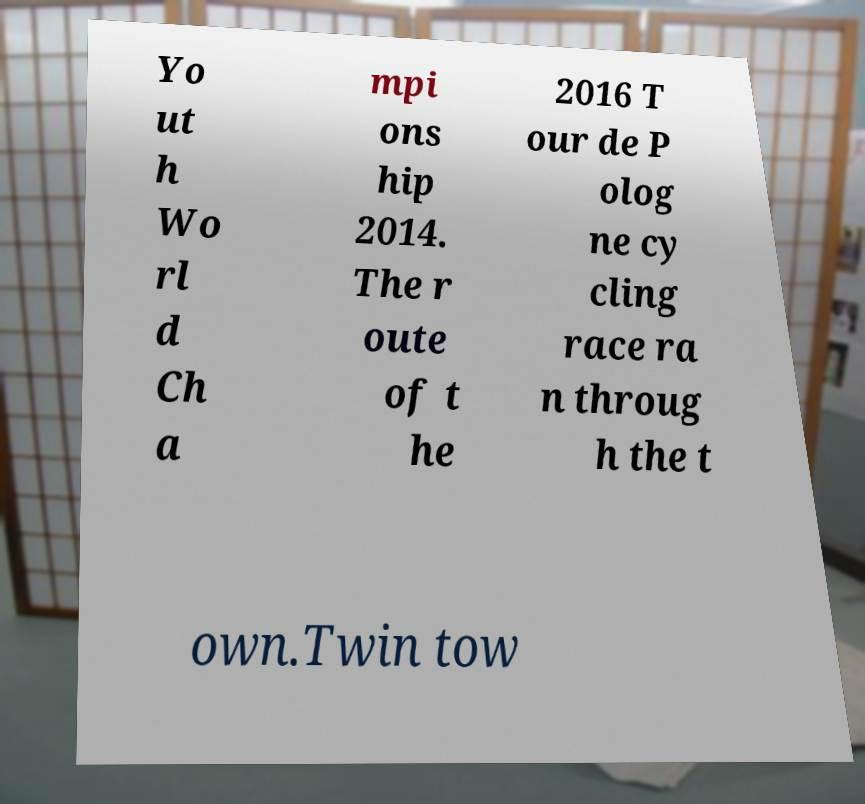Please read and relay the text visible in this image. What does it say? Yo ut h Wo rl d Ch a mpi ons hip 2014. The r oute of t he 2016 T our de P olog ne cy cling race ra n throug h the t own.Twin tow 